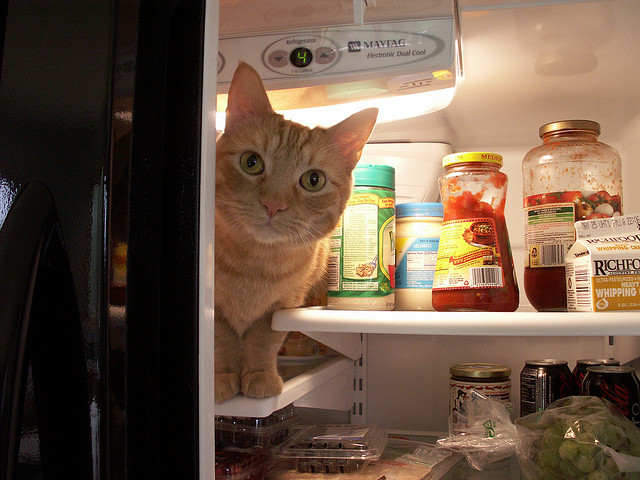Read all the text in this image. MAYTAC 4 WHIPPING RICHFC 